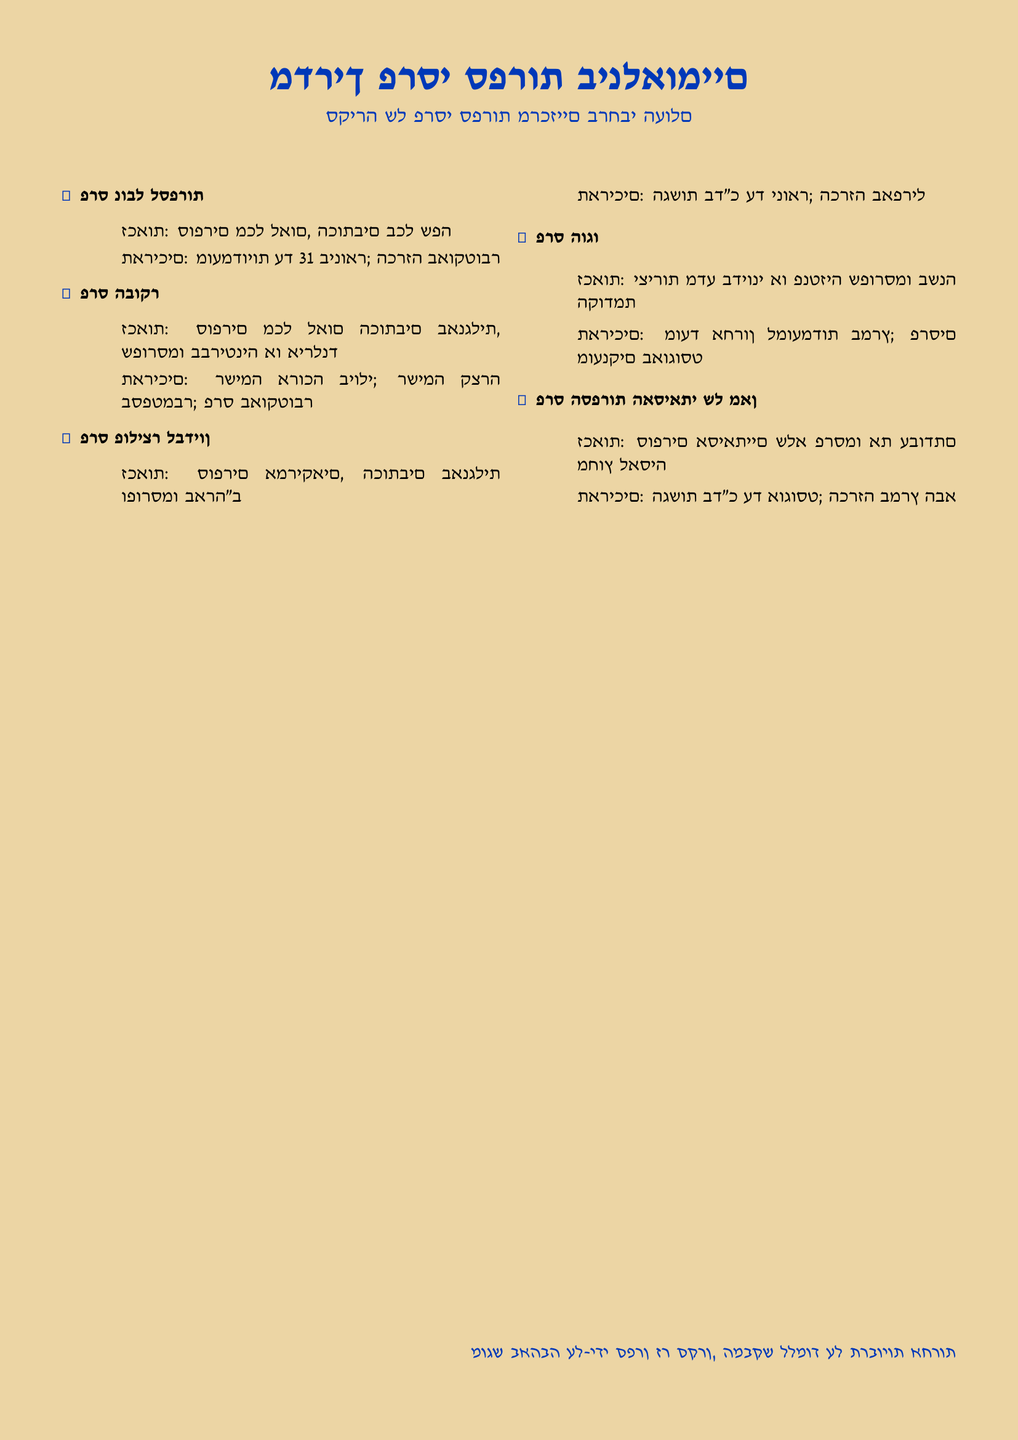What is the title of the document? The title is stated at the top of the document in Hebrew, which is "מדריך פרסי ספרות בינלאומיים."
Answer: מדריך פרסי ספרות בינלאומיים How many literary awards are listed in the document? The document features a list of five different literary awards.
Answer: 5 What is the eligibility for the Nobel Prize in Literature? The eligibility criterion for the Nobel Prize is that it accepts writers of all nationalities writing in any language.
Answer: סופרים מכל לאום, הכותבים בכל שפה What month are the nominations for the Hugo Award due? The document indicates that the deadline for Hugo Award nominations is in March.
Answer: מרץ When is the announcement date for the Asian Man Literary Prize? The announcement for this award occurs in March of the following year after submissions are due in August.
Answer: מרץ הבא What color is used for the heading text? The heading text color chosen in the document is a shade represented by the definition provided in the code.
Answer: hebrewblue Which award requires entries to be published in the US? The Pulitzer Prize for Fiction specifies that entries must be published in the United States.
Answer: פרס פוליצר לבדיון What is the award given in October according to the document? The document lists the announcement for the Booker Prize happening in October.
Answer: פרס הבוקר What does the document indicate about the eligibility for the Hugo Award? The Hugo Award is open to science fiction or fantasy works published in the previous year.
Answer: יצירות מדע בדיוני או פנטזיה שפורסמו בשנה הקודמת 